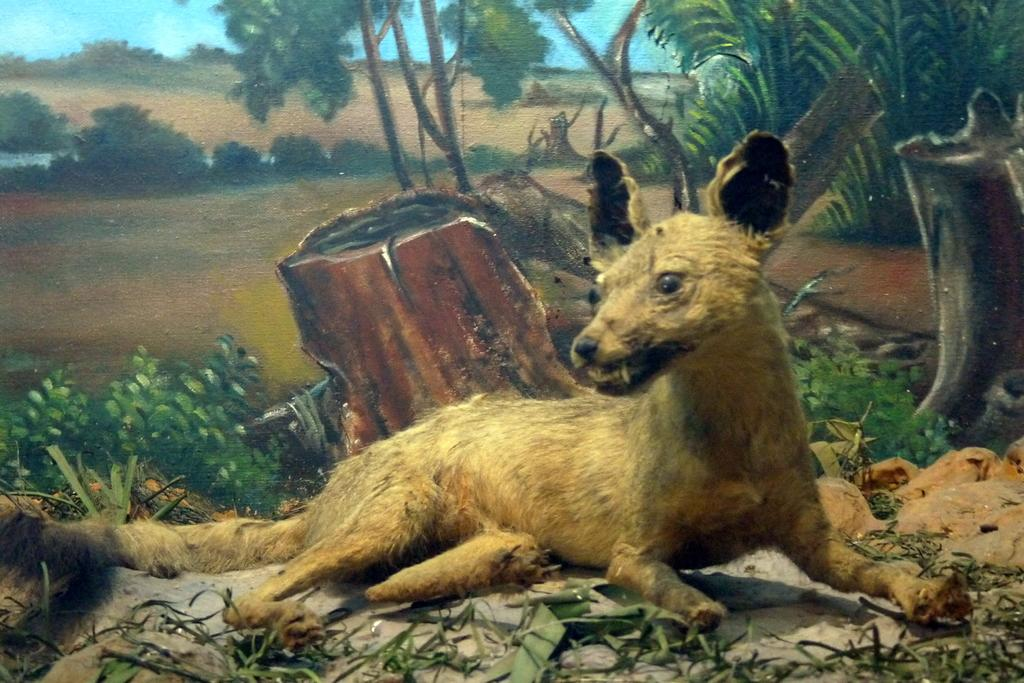What animal can be seen in the painting? The painting contains a dog lying on the ground. What type of vegetation is present in the painting? There are trees, bushes, and shrubs depicted in the painting. What is the ground made of in the painting? Grass is visible in the painting. What can be seen in the sky in the painting? The sky with clouds is depicted in the painting. What type of apple is being smoked by the dog in the painting? There is no apple or smoking depicted in the painting; it features a dog lying on the ground in a natural setting. How quiet is the environment in the painting? The painting does not convey any information about the noise level in the depicted environment. 